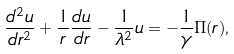Convert formula to latex. <formula><loc_0><loc_0><loc_500><loc_500>\frac { d ^ { 2 } u } { d r ^ { 2 } } + \frac { 1 } { r } \frac { d u } { d r } - \frac { 1 } { \lambda ^ { 2 } } u = - \frac { 1 } { \gamma } \Pi ( r ) ,</formula> 